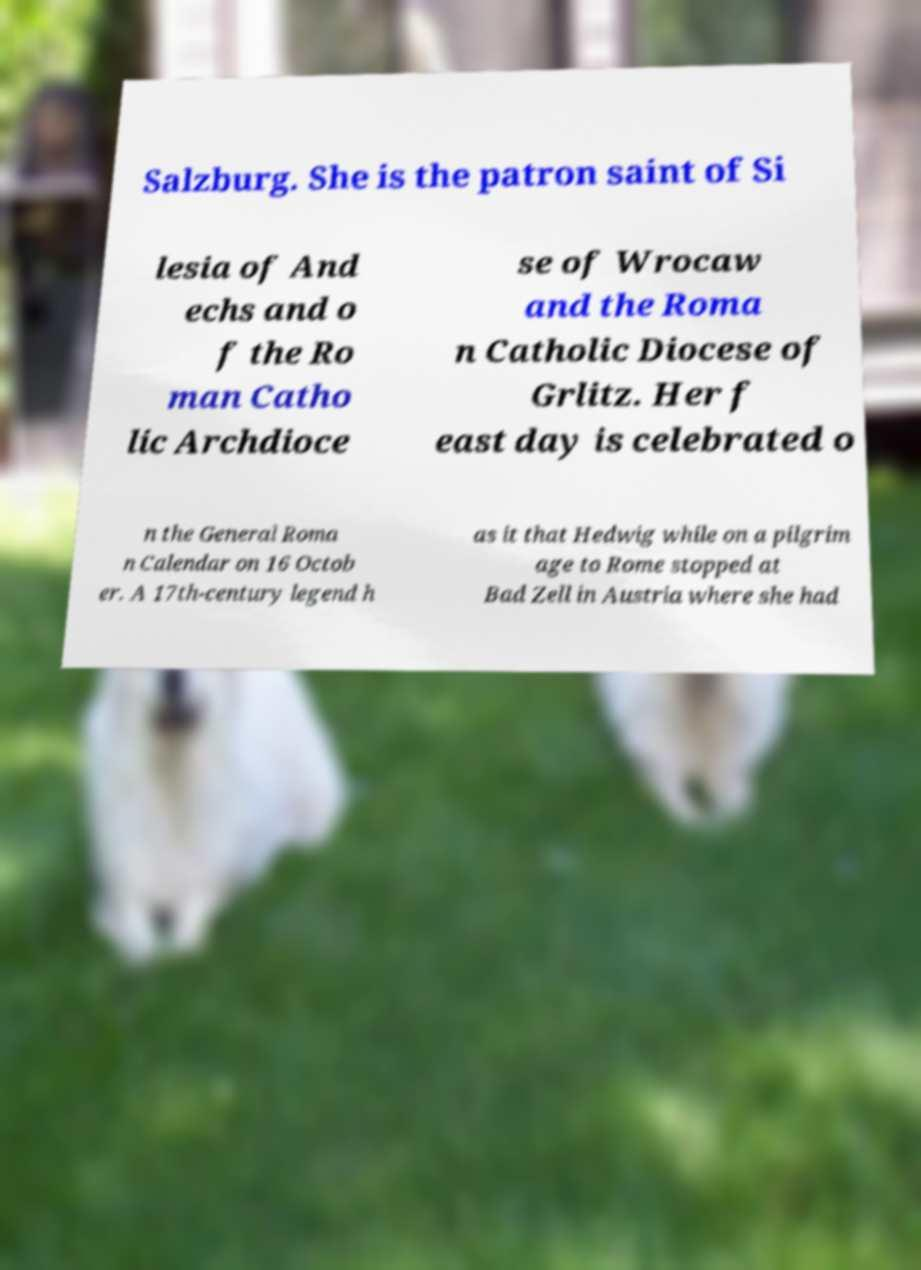Can you accurately transcribe the text from the provided image for me? Salzburg. She is the patron saint of Si lesia of And echs and o f the Ro man Catho lic Archdioce se of Wrocaw and the Roma n Catholic Diocese of Grlitz. Her f east day is celebrated o n the General Roma n Calendar on 16 Octob er. A 17th-century legend h as it that Hedwig while on a pilgrim age to Rome stopped at Bad Zell in Austria where she had 